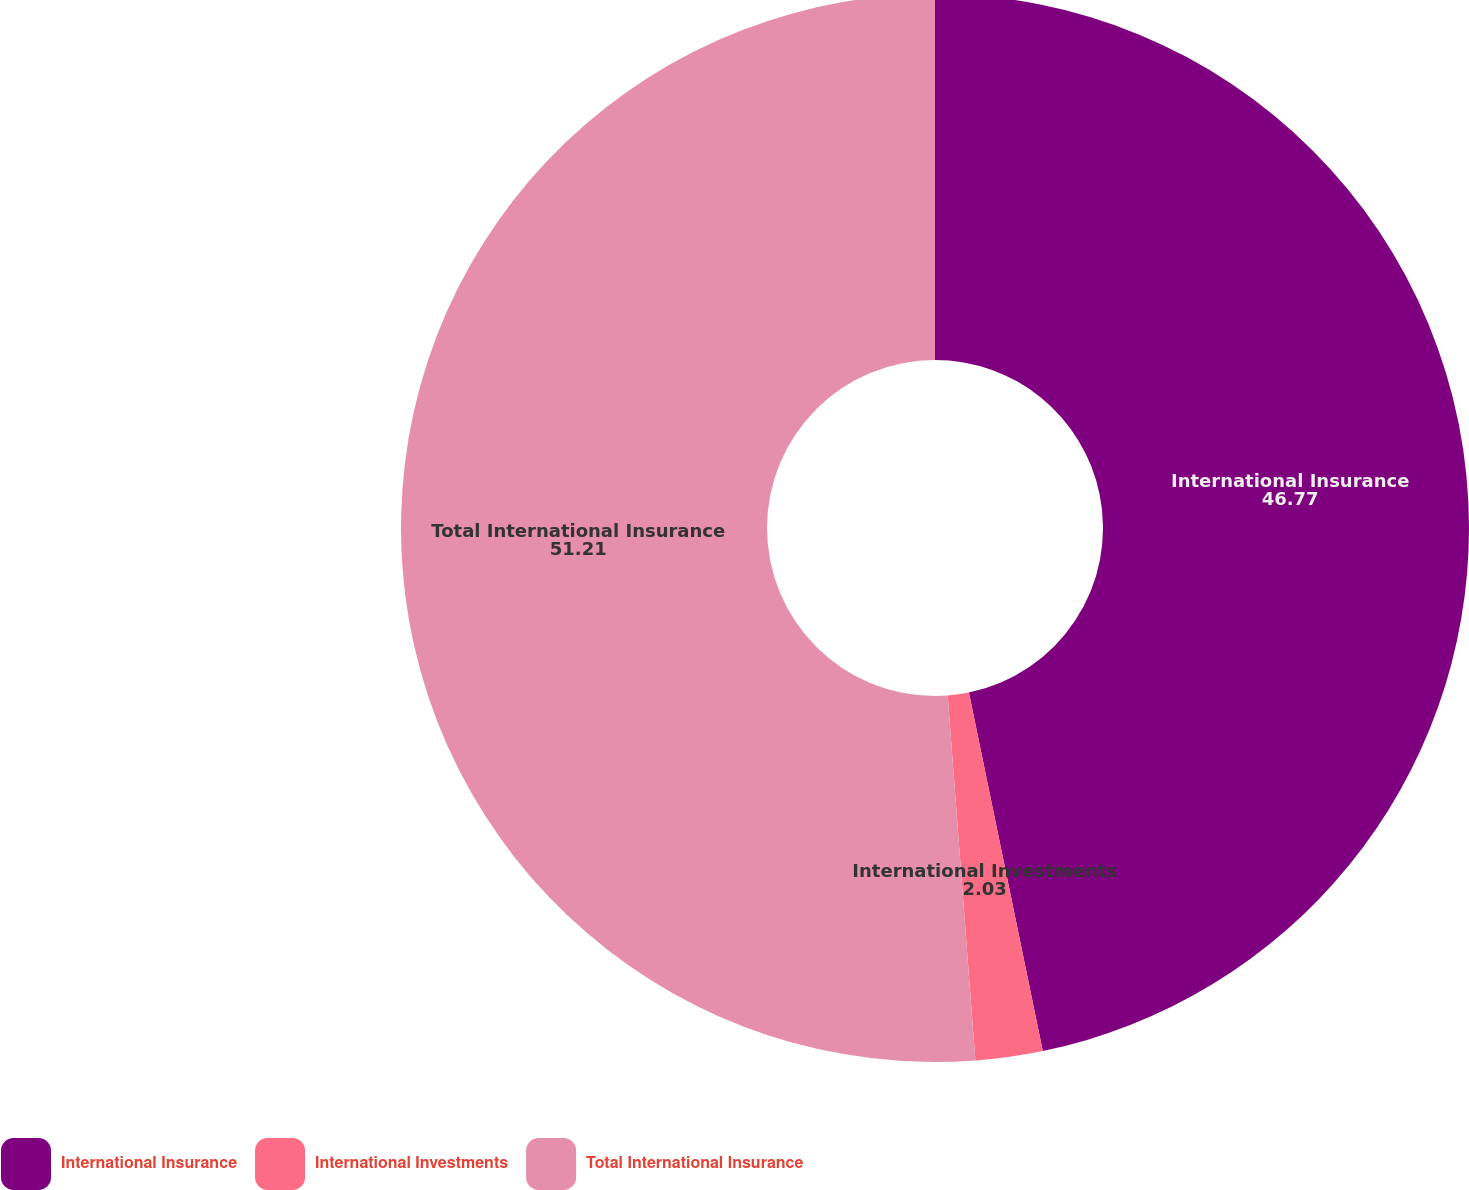Convert chart. <chart><loc_0><loc_0><loc_500><loc_500><pie_chart><fcel>International Insurance<fcel>International Investments<fcel>Total International Insurance<nl><fcel>46.77%<fcel>2.03%<fcel>51.21%<nl></chart> 